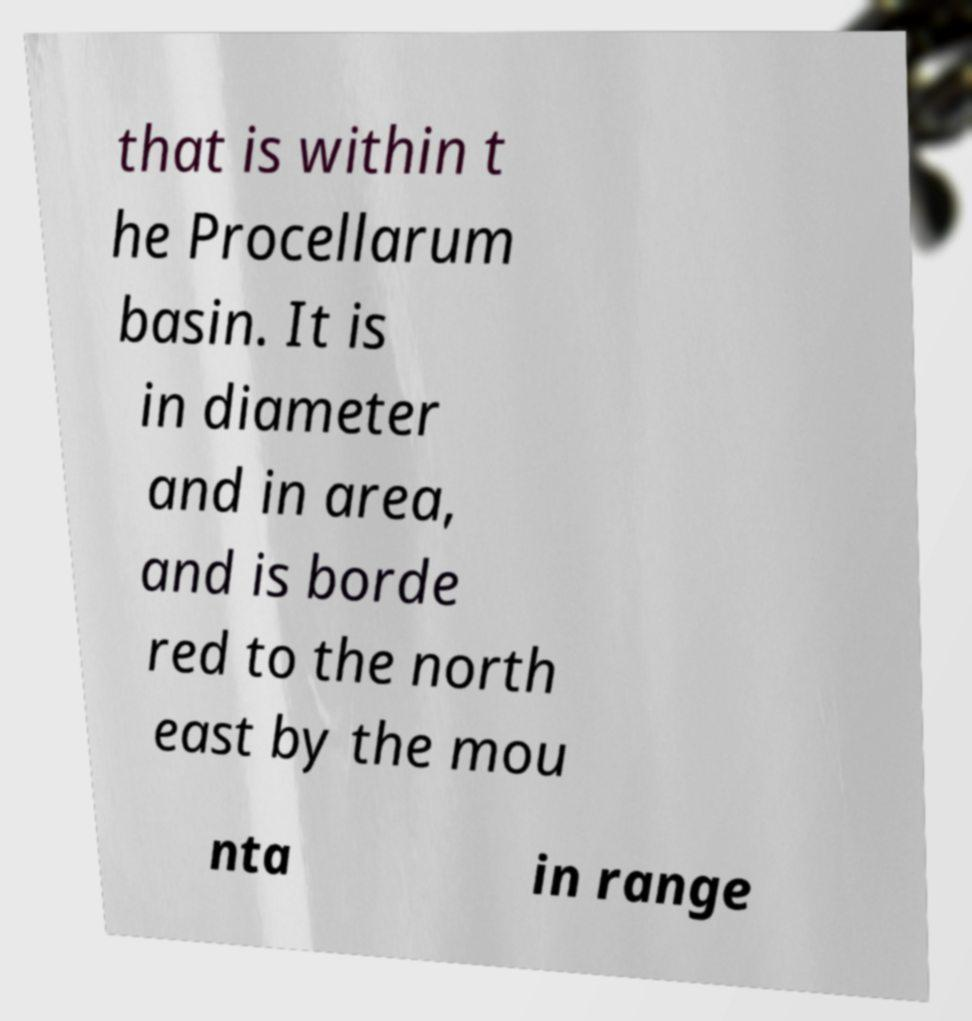Could you extract and type out the text from this image? that is within t he Procellarum basin. It is in diameter and in area, and is borde red to the north east by the mou nta in range 